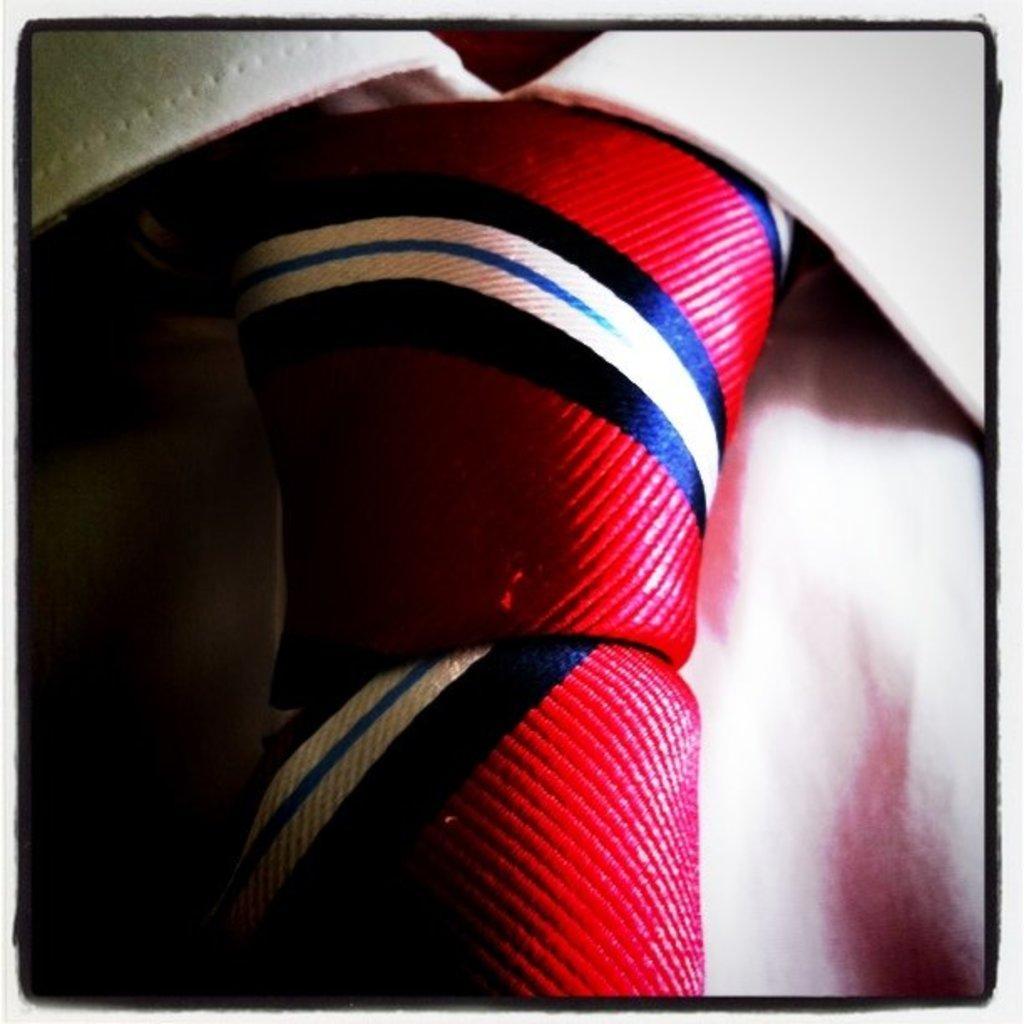In one or two sentences, can you explain what this image depicts? In this image we can see that there is a white color shirt on which there is a red color tie. On the time there are strips. 